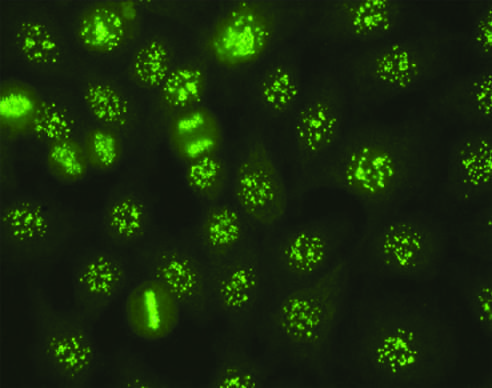s margin p seen with antibodies against various nuclear antigens, including sm and rnps?
Answer the question using a single word or phrase. No 